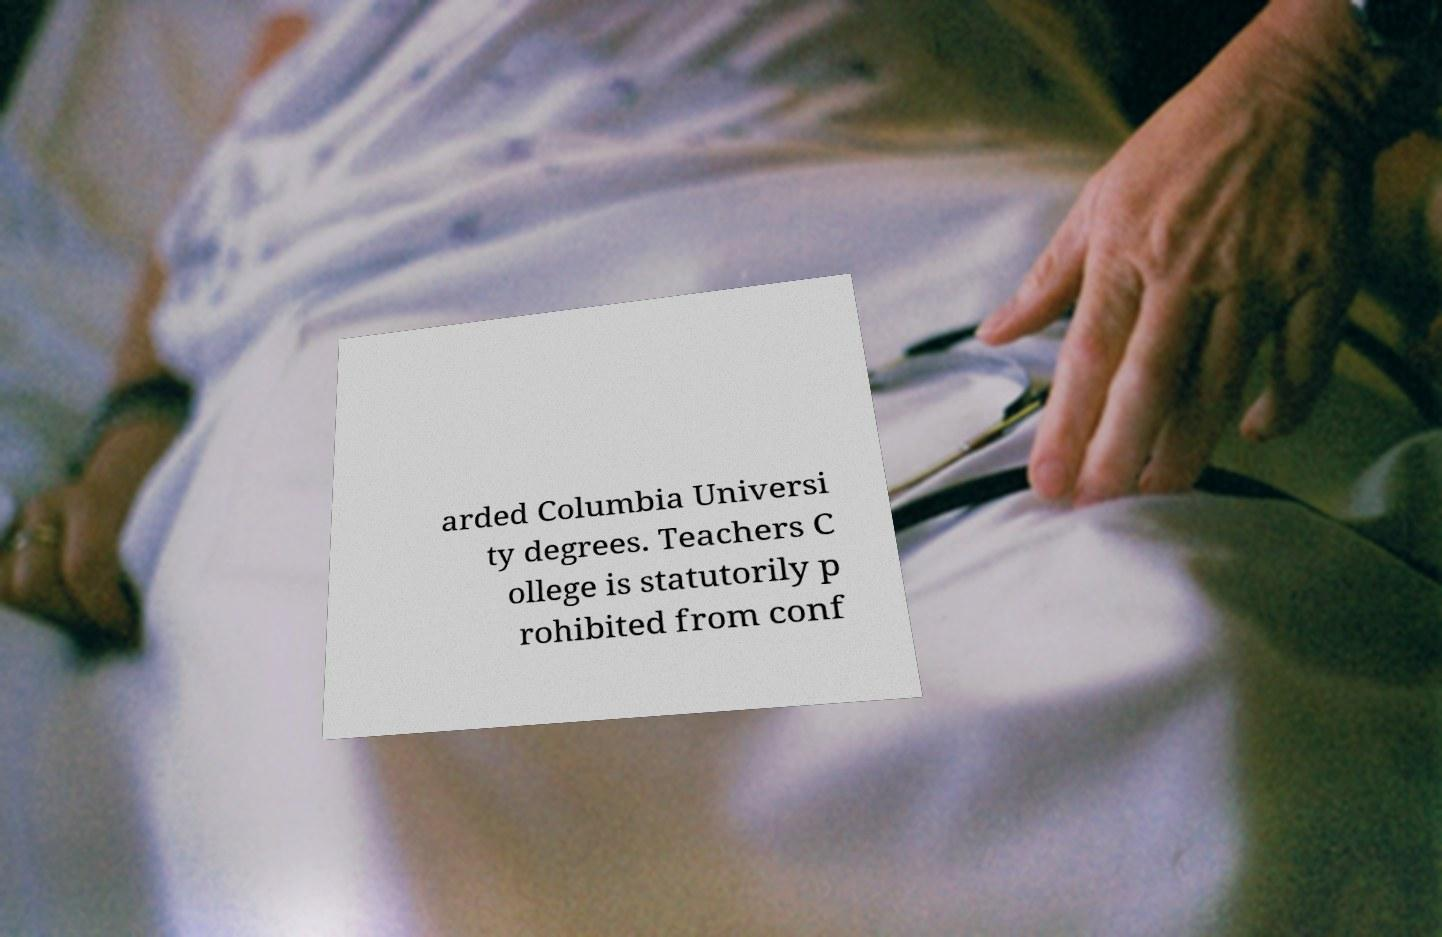There's text embedded in this image that I need extracted. Can you transcribe it verbatim? arded Columbia Universi ty degrees. Teachers C ollege is statutorily p rohibited from conf 